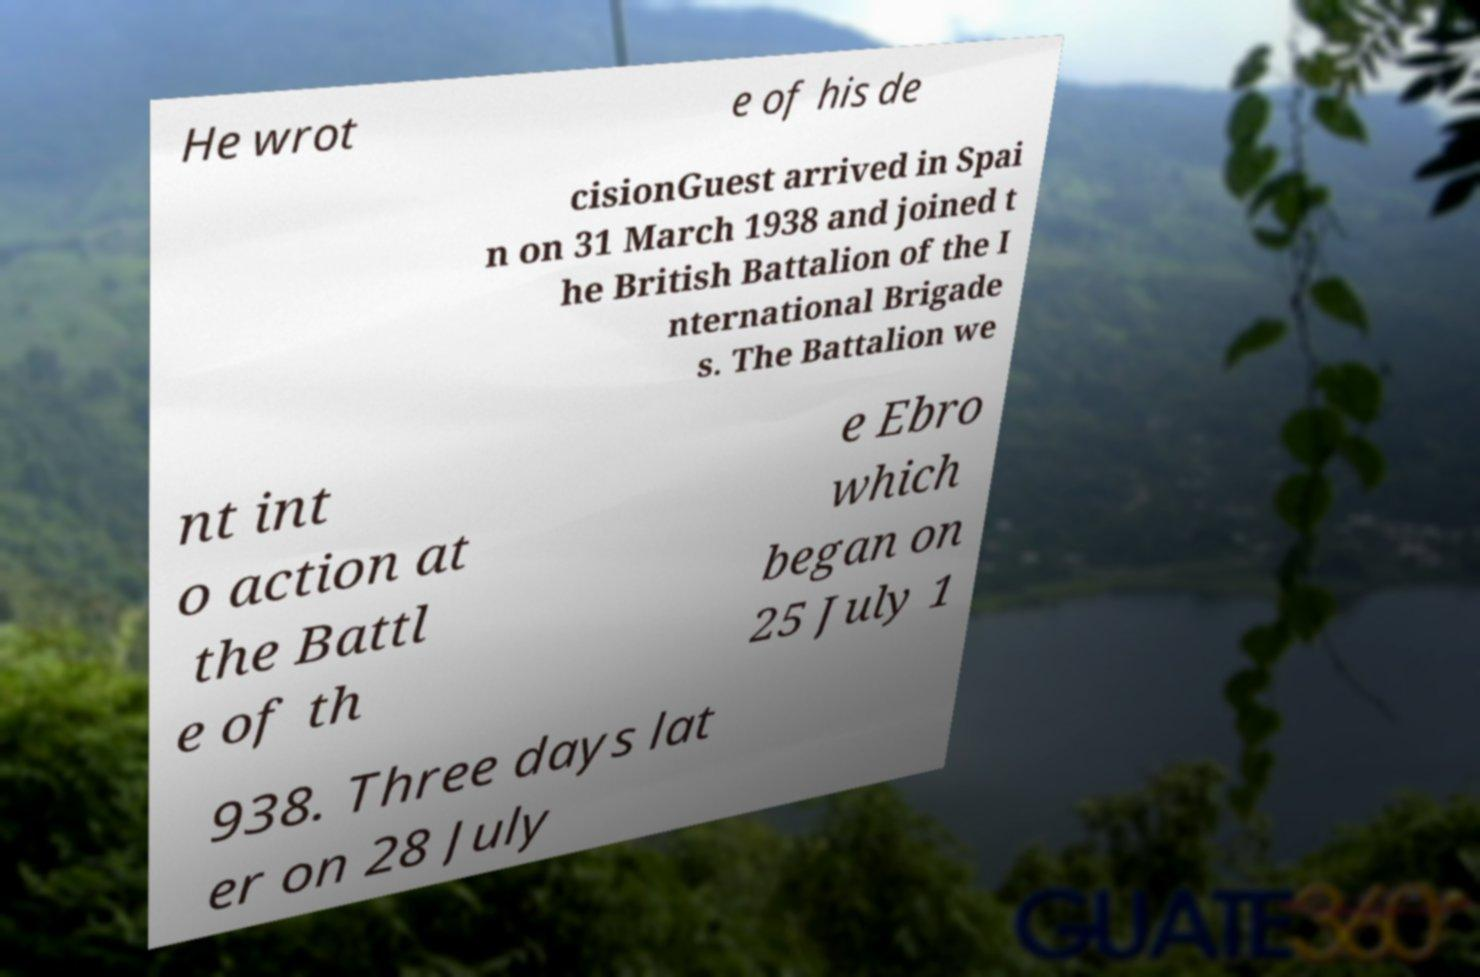Please read and relay the text visible in this image. What does it say? He wrot e of his de cisionGuest arrived in Spai n on 31 March 1938 and joined t he British Battalion of the I nternational Brigade s. The Battalion we nt int o action at the Battl e of th e Ebro which began on 25 July 1 938. Three days lat er on 28 July 